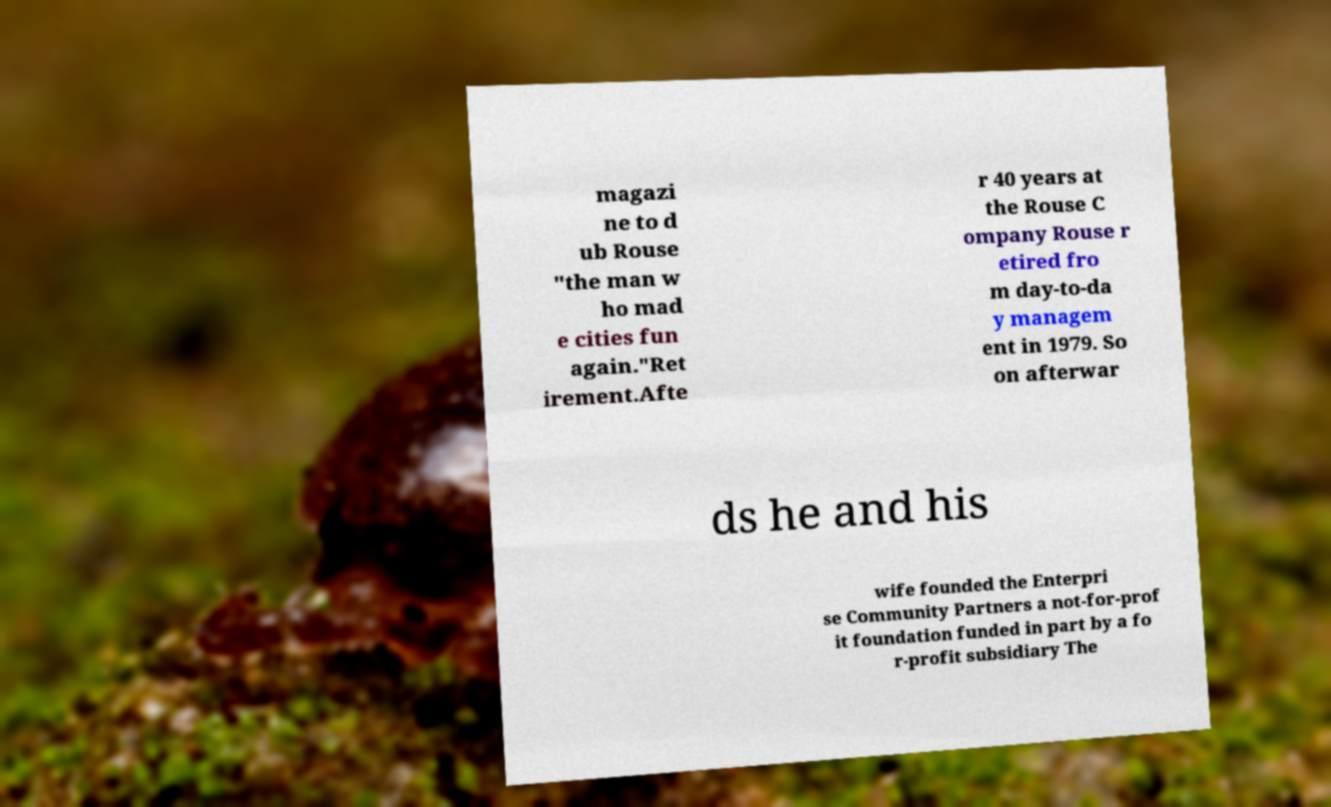Could you extract and type out the text from this image? magazi ne to d ub Rouse "the man w ho mad e cities fun again."Ret irement.Afte r 40 years at the Rouse C ompany Rouse r etired fro m day-to-da y managem ent in 1979. So on afterwar ds he and his wife founded the Enterpri se Community Partners a not-for-prof it foundation funded in part by a fo r-profit subsidiary The 